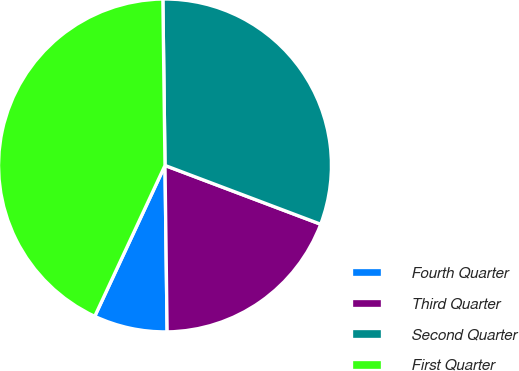Convert chart. <chart><loc_0><loc_0><loc_500><loc_500><pie_chart><fcel>Fourth Quarter<fcel>Third Quarter<fcel>Second Quarter<fcel>First Quarter<nl><fcel>7.14%<fcel>19.05%<fcel>30.95%<fcel>42.86%<nl></chart> 